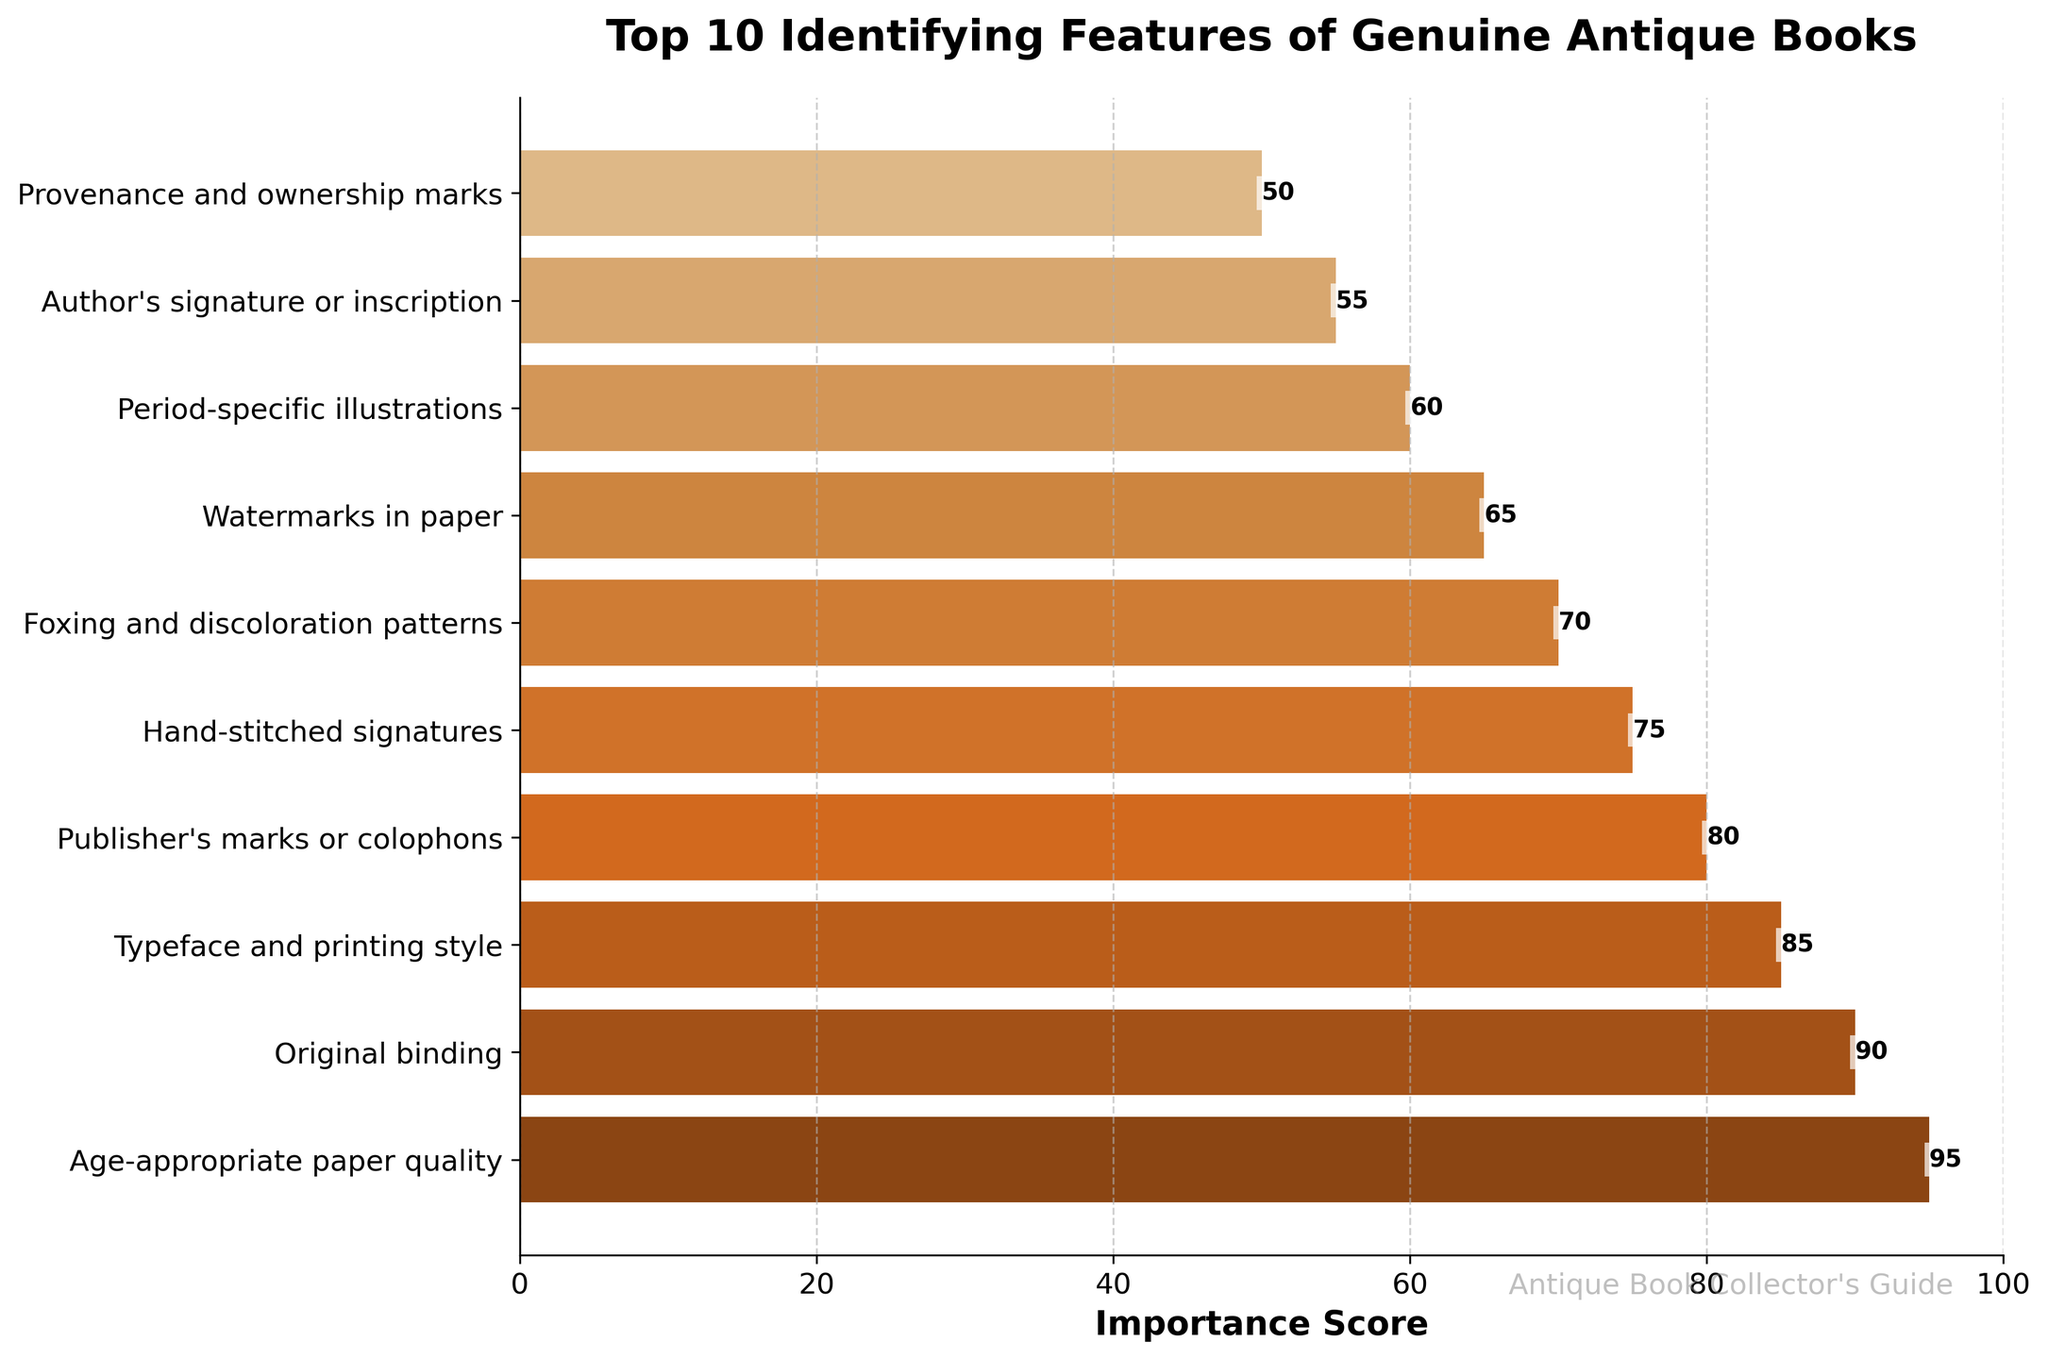What's the most important feature for identifying genuine antique books? The bar chart shows the importance scores for each feature. The highest bar represents the most important feature. The feature with the highest score of 95 is "Age-appropriate paper quality".
Answer: Age-appropriate paper quality How much more important is "Original binding" compared to "Provenance and ownership marks"? By reading the scores from the bar chart, "Original binding" has a score of 90, and "Provenance and ownership marks" has 50. The difference is 90 - 50 = 40.
Answer: 40 Which feature has the smallest importance score, and what is its value? The feature with the smallest bar represents the feature with the lowest score. The shortest bar corresponds to "Provenance and ownership marks" with a score of 50.
Answer: Provenance and ownership marks, 50 Combine the importance scores of "Typeface and printing style" and "Publisher's marks or colophons". What is their total? The score for "Typeface and printing style" is 85, and the score for "Publisher's marks or colophons" is 80. Adding these together gives 85 + 80 = 165.
Answer: 165 Which feature has a higher importance score: "Period-specific illustrations" or "Foxing and discoloration patterns"? Comparing the scores from the bar chart, "Foxing and discoloration patterns" has a score of 70, while "Period-specific illustrations" has a score of 60. Since 70 > 60, "Foxing and discoloration patterns" is higher.
Answer: Foxing and discoloration patterns What is the average importance score of the top 5 features? The top 5 features based on their importance scores are: "Age-appropriate paper quality" (95), "Original binding" (90), "Typeface and printing style" (85), "Publisher's marks or colophons" (80), and "Hand-stitched signatures" (75). The sum of these scores is 95 + 90 + 85 + 80 + 75 = 425. Dividing by 5, the average is 425 / 5 = 85.
Answer: 85 Is the importance score of "Watermarks in paper" closer to "Hand-stitched signatures" or "Period-specific illustrations"? The importance score of "Watermarks in paper" is 65. The score for "Hand-stitched signatures" is 75, giving a difference of 75 - 65 = 10. The score for "Period-specific illustrations" is 60, with a difference of 65 - 60 = 5. Since 5 < 10, "Watermarks in paper" is closer to "Period-specific illustrations".
Answer: Period-specific illustrations Are all importance scores above 50? By examining all the bars in the chart, the lowest importance score shown is 50 for the "Provenance and ownership marks" feature. Since no bars are below this value, all scores are above 50.
Answer: Yes Which feature appears with a visual gap between itself and the next lower-scoring feature? "Hand-stitched signatures" with a score of 75 exhibits the largest visual gap before the bar representing "Foxing and discoloration patterns" with a score of 70.
Answer: Hand-stitched signatures 